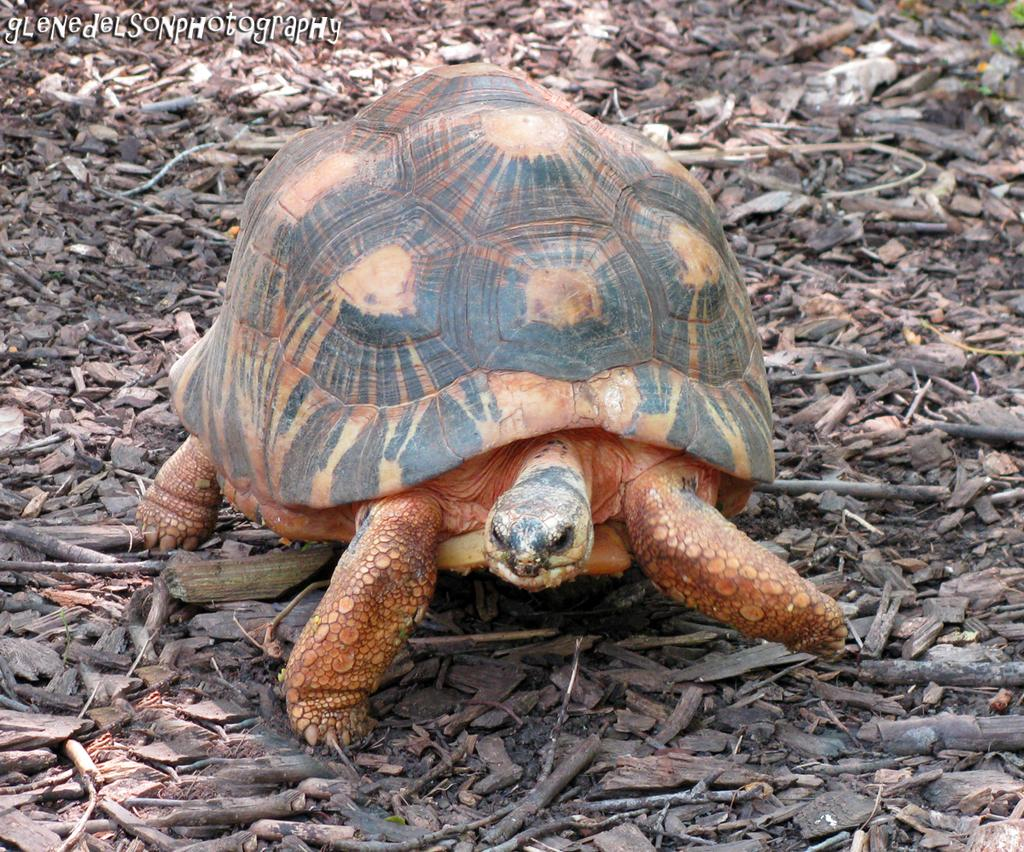What type of animal is in the image? There is a tortoise in the image. What colors can be seen on the tortoise? The tortoise is black and brown in color. What is the tortoise resting on in the image? The tortoise is on wooden sticks. What colors can be seen on the wooden sticks? The wooden sticks are brown and black in color. What type of sweater is the tortoise wearing in the image? There is no sweater present in the image; the tortoise is not wearing any clothing. How does the tortoise feel about being on wooden sticks in the image? The image does not provide any information about the tortoise's feelings or emotions. Can you find a circle in the image? There is no circle present in the image. 